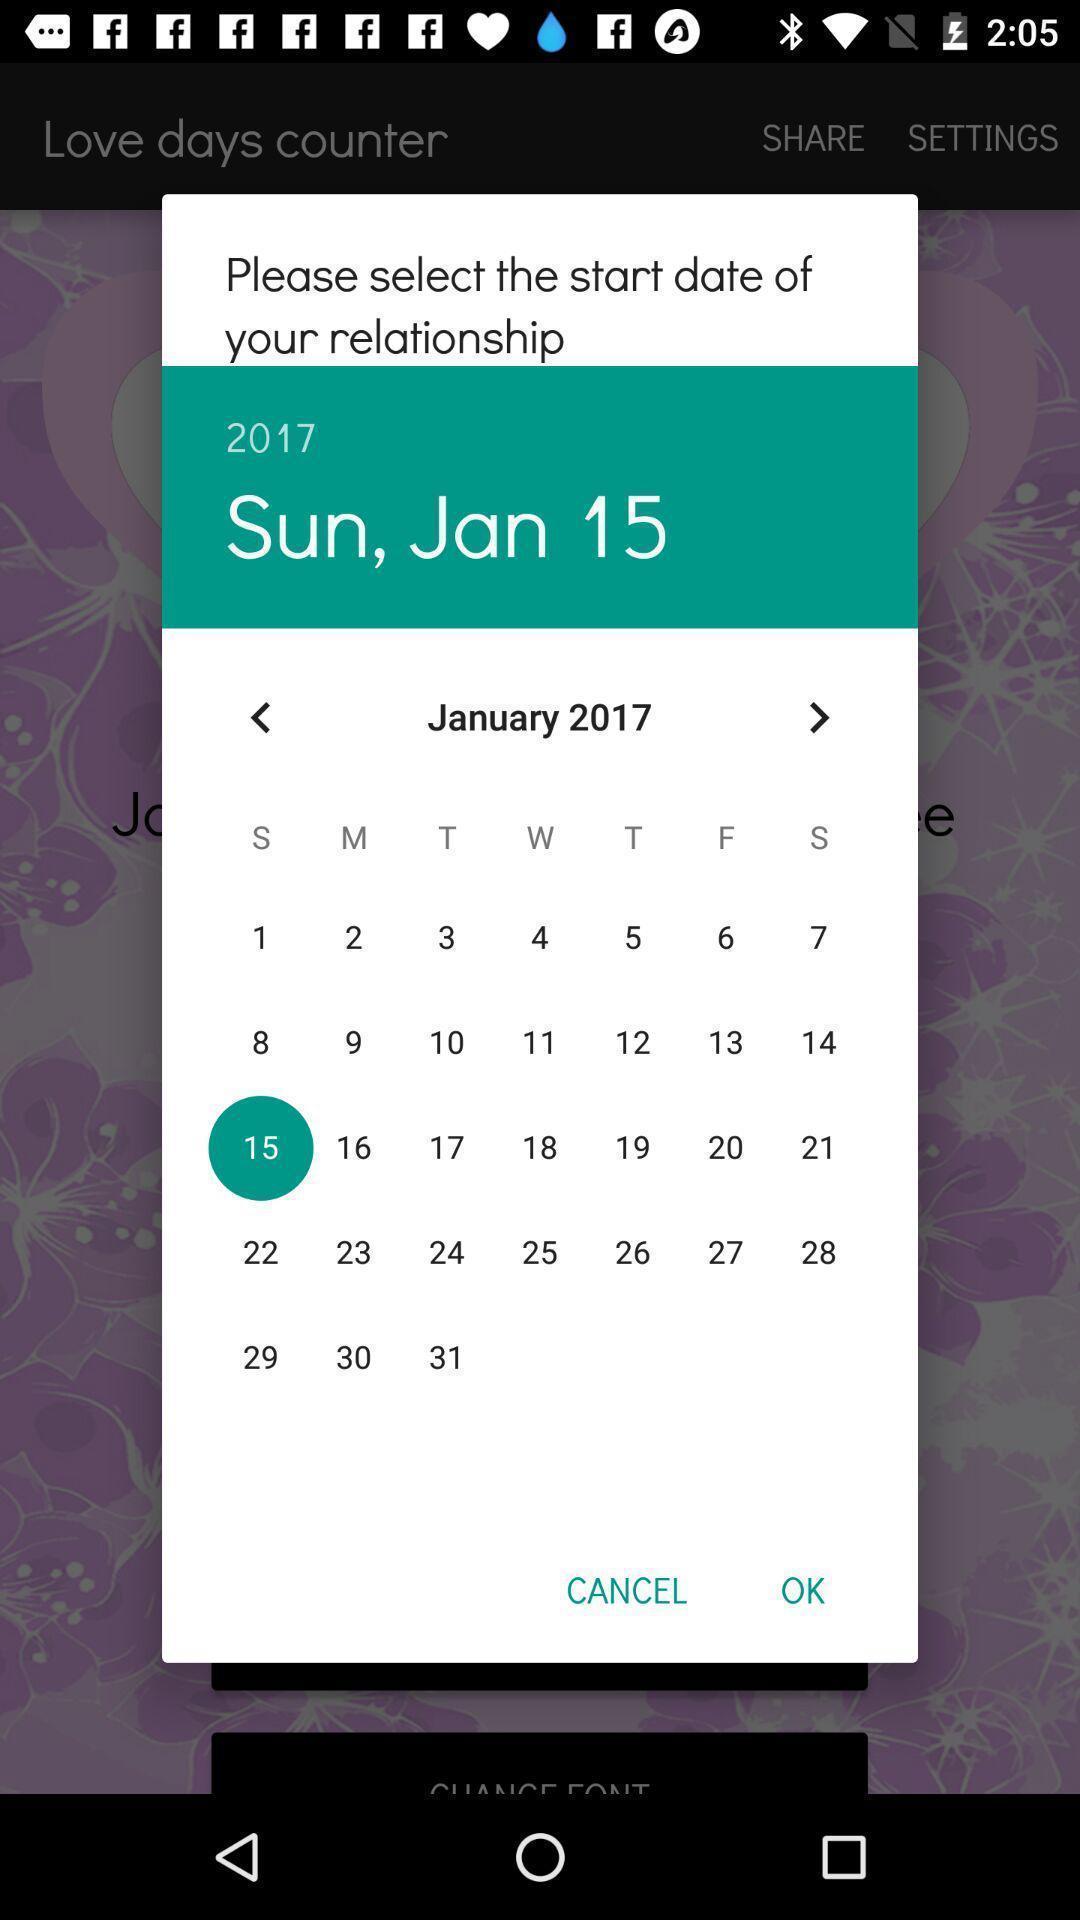What can you discern from this picture? Screen shows to select a start date of a relationship. 